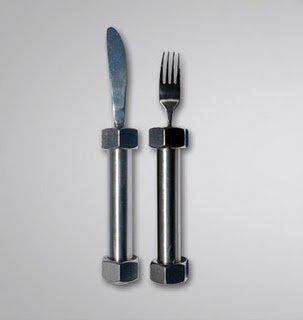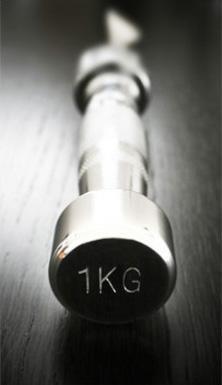The first image is the image on the left, the second image is the image on the right. Considering the images on both sides, is "One image shows a matched set of knife, fork, and spoon utensils." valid? Answer yes or no. No. 